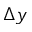Convert formula to latex. <formula><loc_0><loc_0><loc_500><loc_500>\Delta y</formula> 